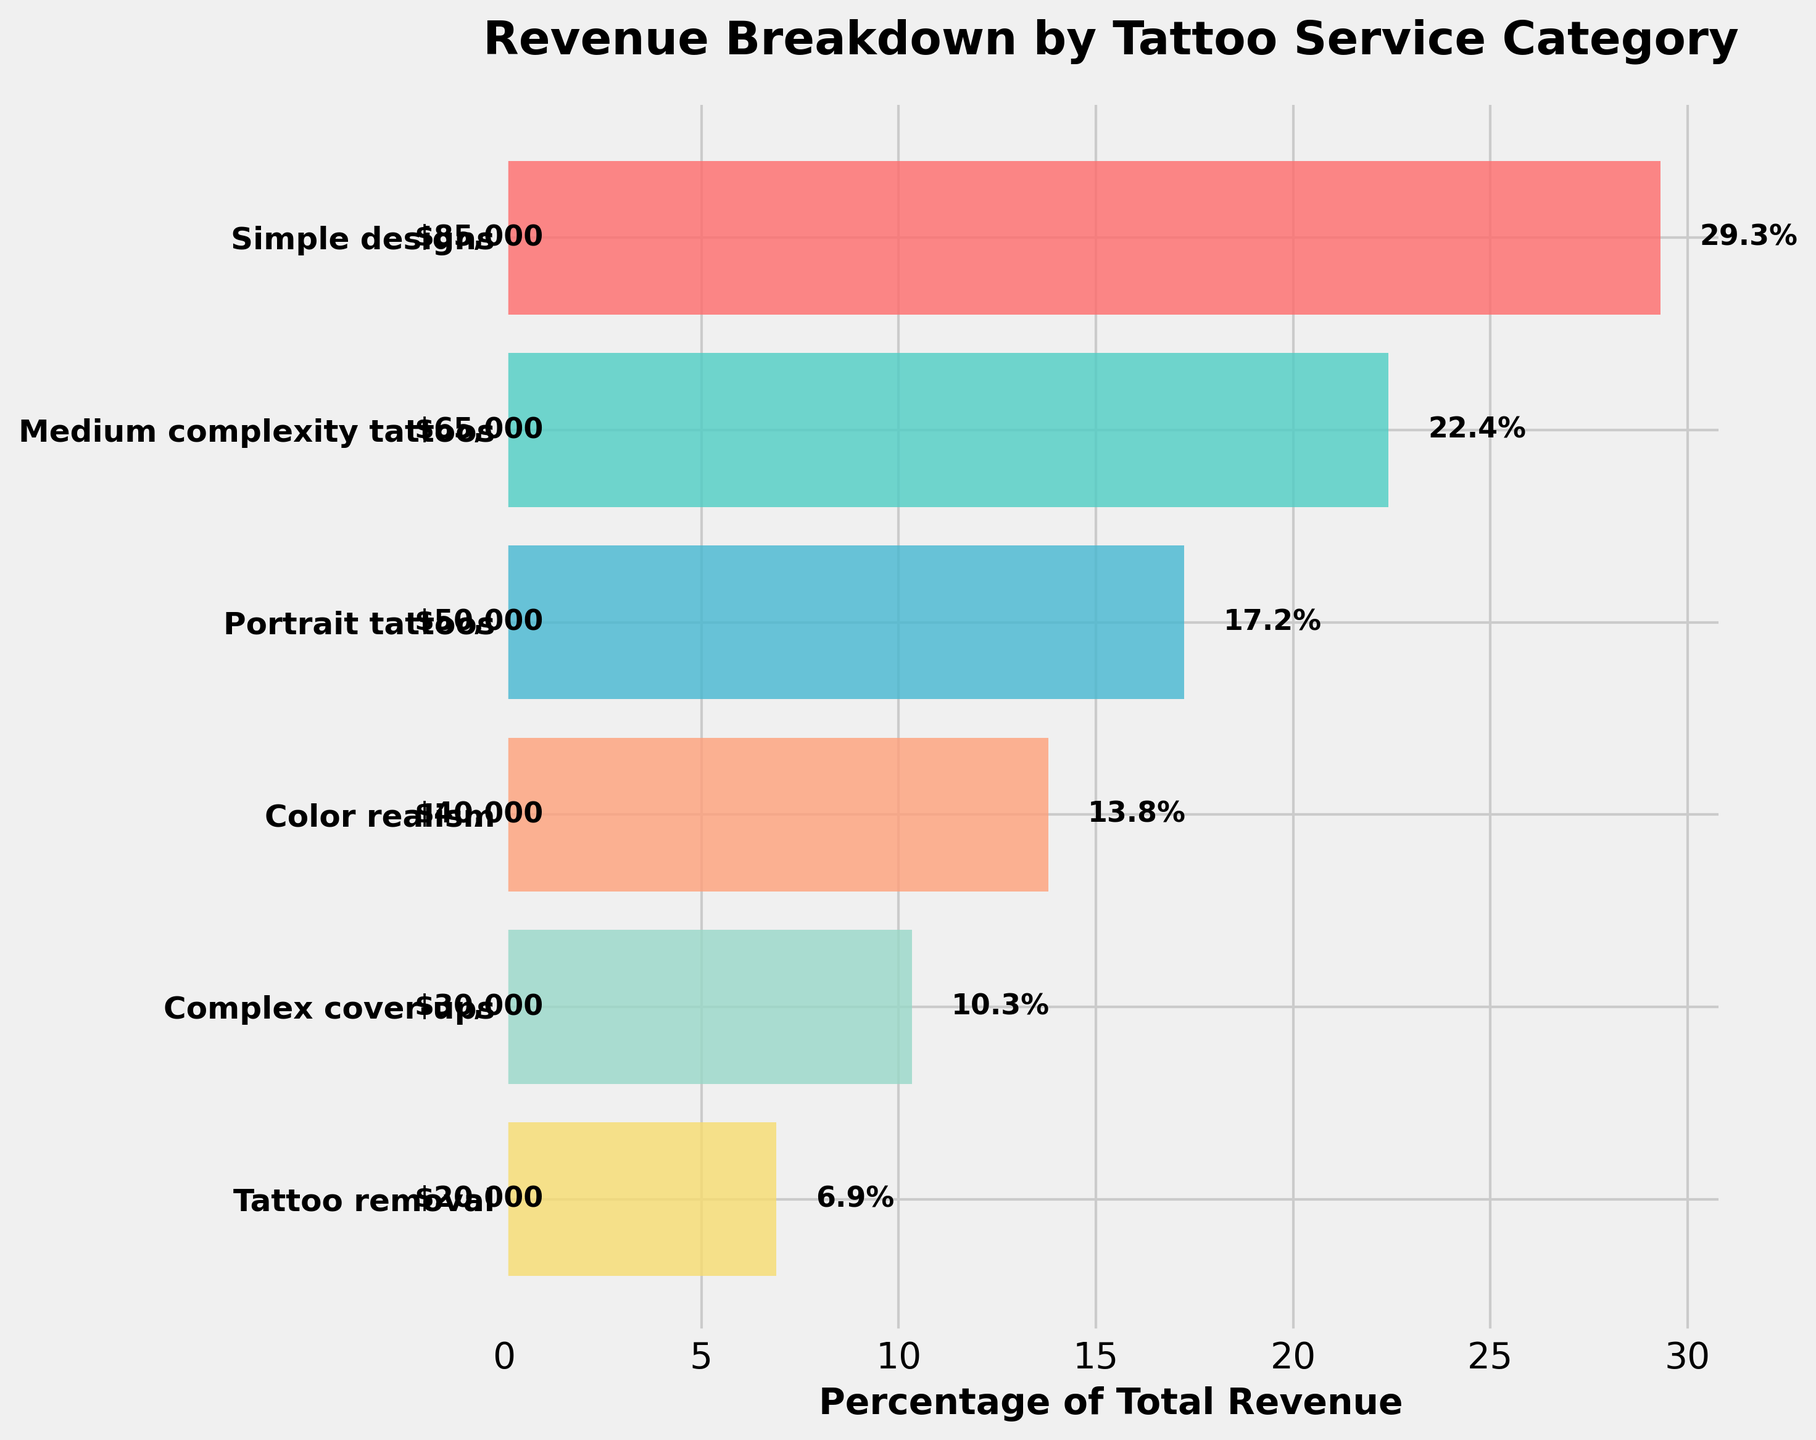What is the title of the chart? The title of the chart is displayed at the top, above the funnel plot. It reads "Revenue Breakdown by Tattoo Service Category".
Answer: Revenue Breakdown by Tattoo Service Category What percentage of the total revenue does the "Simple designs" category contribute? The "Simple designs" category shows a bar reaching approximately 34.7%, indicated by a label next to it.
Answer: 34.7% How much revenue does the "Color realism" service generate? The bar corresponding to "Color realism" has a label of "$40,000", indicating its revenue contribution.
Answer: $40,000 Which service has the least revenue, and what is its percentage of total revenue? The smallest bar at the bottom belongs to "Tattoo removal", with its label showing "8.2%".
Answer: Tattoo removal, 8.2% Compare the revenue from "Medium complexity tattoos" and "Portrait tattoos". Which one generates more revenue, and by how much? "Medium complexity tattoos" shows a revenue of $65,000 while "Portrait tattoos" shows $50,000. The difference is $65,000 - $50,000 = $15,000.
Answer: Medium complexity tattoos, $15,000 What is the combined revenue from the services "Complex cover-ups" and "Tattoo removal"? The revenue for "Complex cover-ups" is $30,000, and for "Tattoo removal", it's $20,000. Adding them together gives $30,000 + $20,000 = $50,000.
Answer: $50,000 In terms of revenue, which service is ranked third from the top? Ranking from top to bottom based on revenue, "Portrait tattoos" is the third service listed.
Answer: Portrait tattoos What is the approximate percentage of total revenue accounted for by the services generating less than $50,000 each? "Color realism" (13.7%), "Complex cover-ups" (10.3%), and "Tattoo removal" (8.2%). Adding these percentages gives approximately 13.7% + 10.3% + 8.2% = 32.2%.
Answer: 32.2% How many services generate more revenue than "Complex cover-ups"? The chart shows "Simple designs", "Medium complexity tattoos", "Portrait tattoos", and "Color realism" generate more than "Complex cover-ups". There are 4 such services.
Answer: 4 